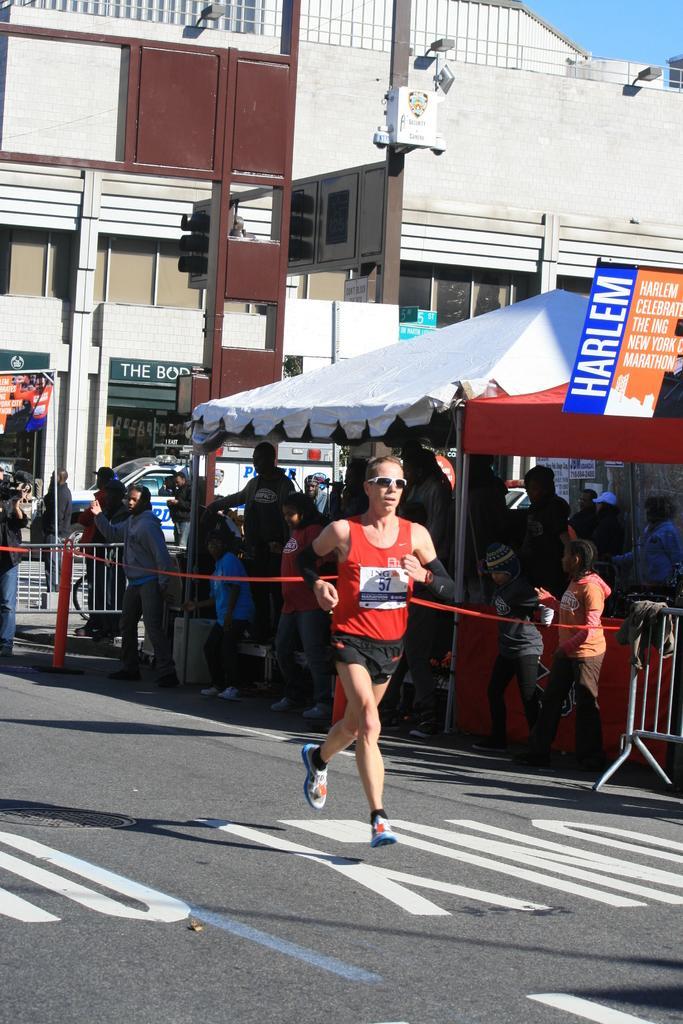Describe this image in one or two sentences. In this image I can see a person running on the road , on the right side I can see a tent and under the tent few persons standing and at the top I can see the building and the sky 